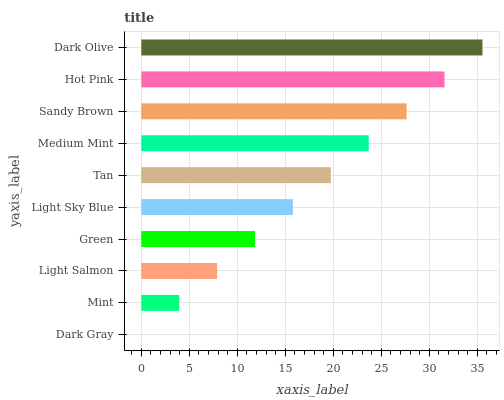Is Dark Gray the minimum?
Answer yes or no. Yes. Is Dark Olive the maximum?
Answer yes or no. Yes. Is Mint the minimum?
Answer yes or no. No. Is Mint the maximum?
Answer yes or no. No. Is Mint greater than Dark Gray?
Answer yes or no. Yes. Is Dark Gray less than Mint?
Answer yes or no. Yes. Is Dark Gray greater than Mint?
Answer yes or no. No. Is Mint less than Dark Gray?
Answer yes or no. No. Is Tan the high median?
Answer yes or no. Yes. Is Light Sky Blue the low median?
Answer yes or no. Yes. Is Light Sky Blue the high median?
Answer yes or no. No. Is Sandy Brown the low median?
Answer yes or no. No. 